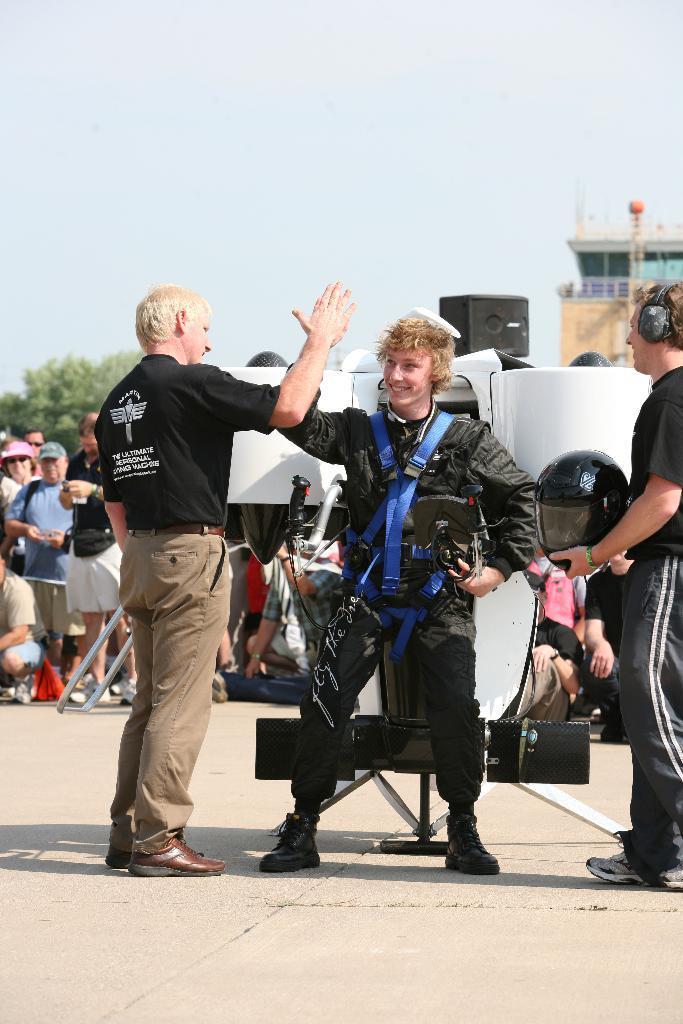Please provide a concise description of this image. In this image I can see three persons. One person is holding a helmet in his hands. In the background I can see few people. I can see a tree and a building. At the top I can see the sky. 